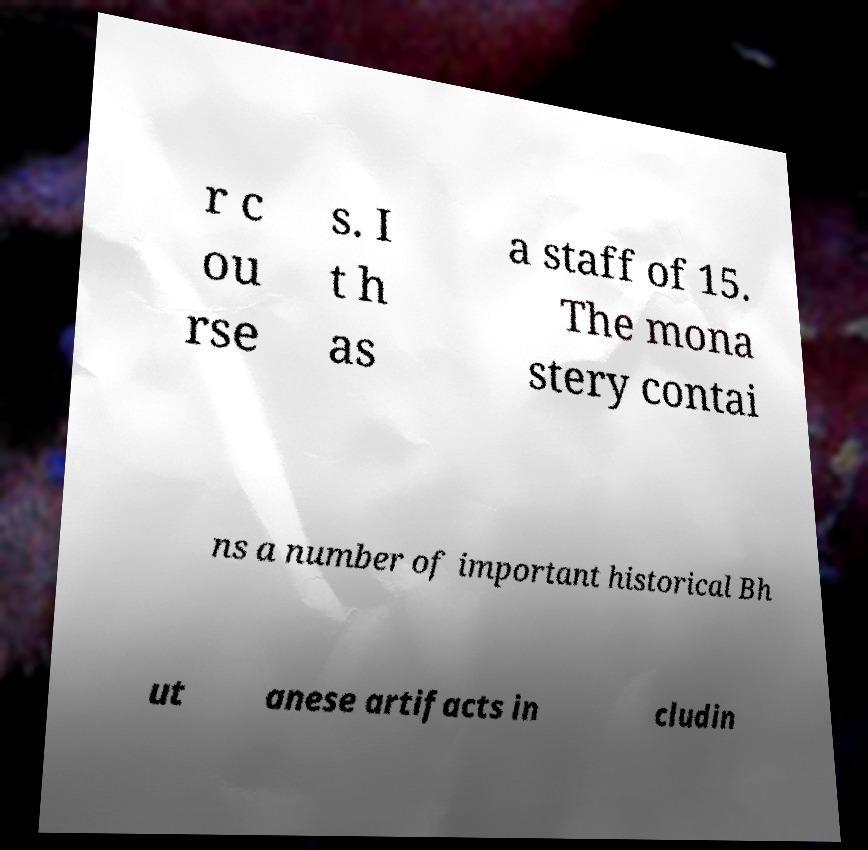Could you extract and type out the text from this image? r c ou rse s. I t h as a staff of 15. The mona stery contai ns a number of important historical Bh ut anese artifacts in cludin 